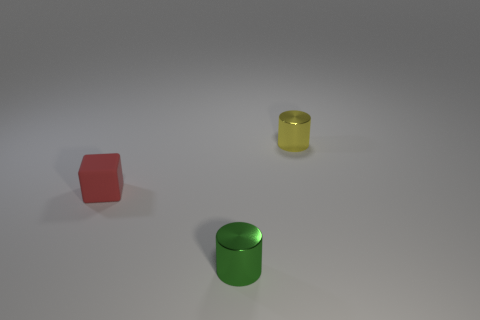The green shiny cylinder has what size? The green shiny cylinder appears to be of medium size relative to the context of the image, which includes other shapes such as a smaller red cube and a smaller, possibly transparent yellow cylinder. 